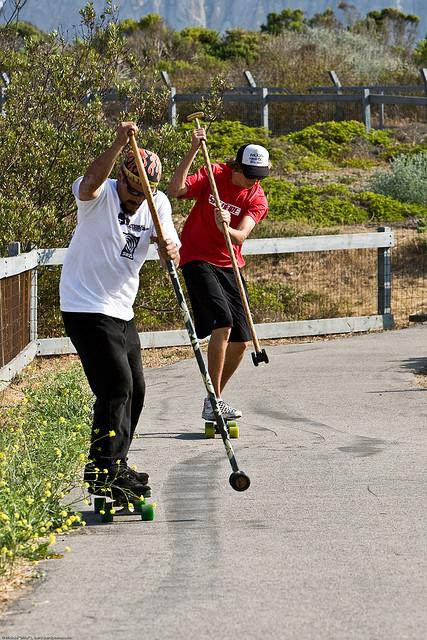What are the men riding on? skateboard 